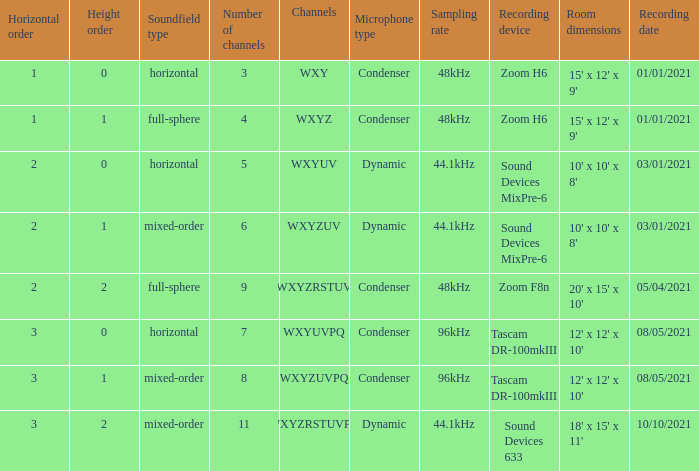If the channels is wxyzrstuvpq, what is the horizontal order? 3.0. 